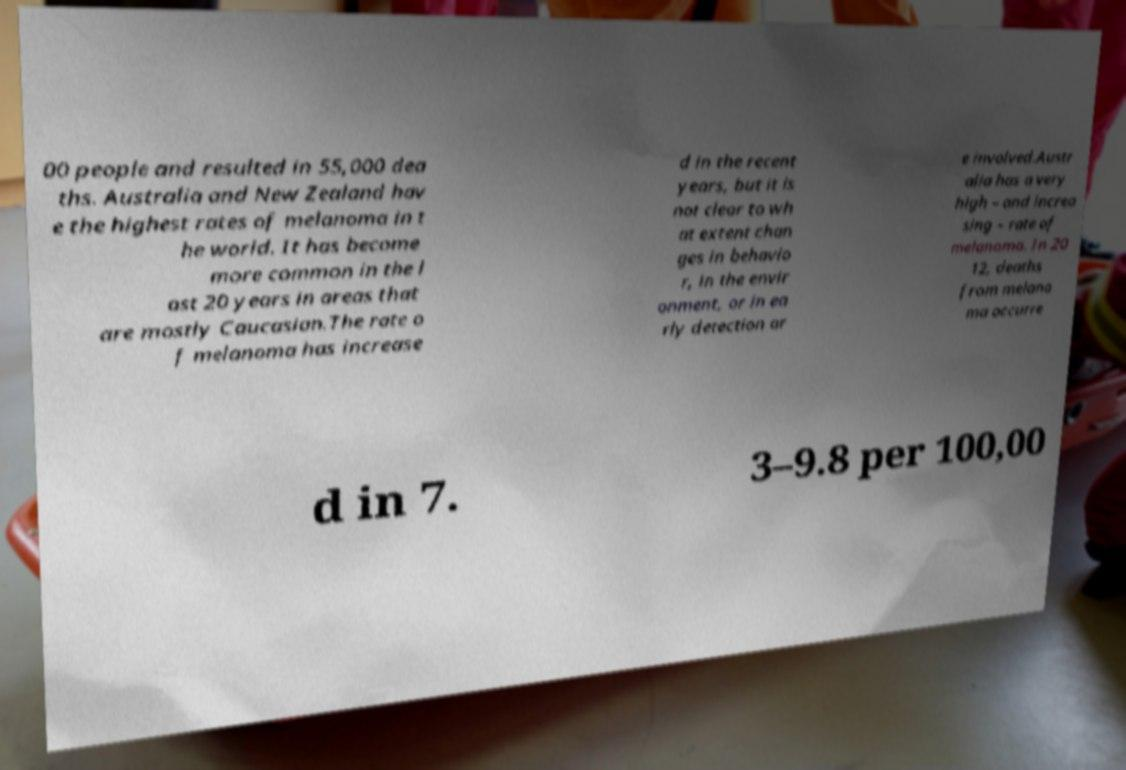Could you assist in decoding the text presented in this image and type it out clearly? 00 people and resulted in 55,000 dea ths. Australia and New Zealand hav e the highest rates of melanoma in t he world. It has become more common in the l ast 20 years in areas that are mostly Caucasian.The rate o f melanoma has increase d in the recent years, but it is not clear to wh at extent chan ges in behavio r, in the envir onment, or in ea rly detection ar e involved.Austr alia has a very high – and increa sing – rate of melanoma. In 20 12, deaths from melano ma occurre d in 7. 3–9.8 per 100,00 